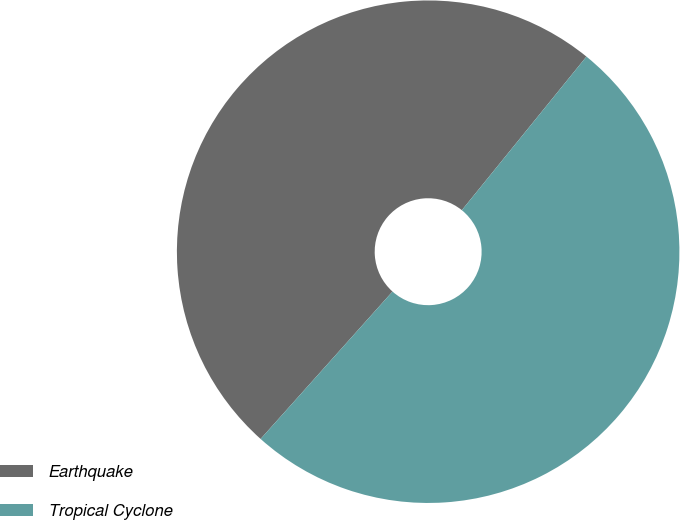Convert chart. <chart><loc_0><loc_0><loc_500><loc_500><pie_chart><fcel>Earthquake<fcel>Tropical Cyclone<nl><fcel>49.23%<fcel>50.77%<nl></chart> 